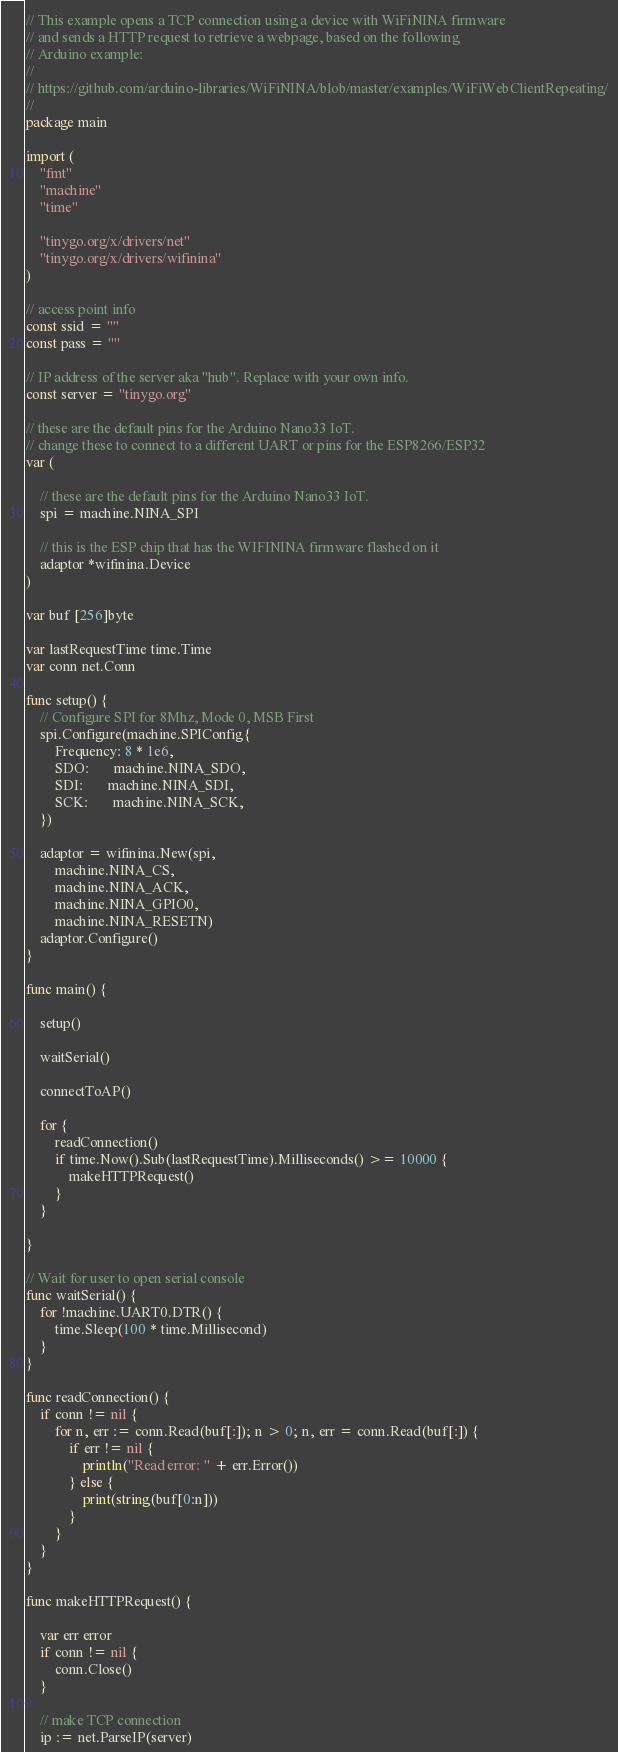<code> <loc_0><loc_0><loc_500><loc_500><_Go_>// This example opens a TCP connection using a device with WiFiNINA firmware
// and sends a HTTP request to retrieve a webpage, based on the following
// Arduino example:
//
// https://github.com/arduino-libraries/WiFiNINA/blob/master/examples/WiFiWebClientRepeating/
//
package main

import (
	"fmt"
	"machine"
	"time"

	"tinygo.org/x/drivers/net"
	"tinygo.org/x/drivers/wifinina"
)

// access point info
const ssid = ""
const pass = ""

// IP address of the server aka "hub". Replace with your own info.
const server = "tinygo.org"

// these are the default pins for the Arduino Nano33 IoT.
// change these to connect to a different UART or pins for the ESP8266/ESP32
var (

	// these are the default pins for the Arduino Nano33 IoT.
	spi = machine.NINA_SPI

	// this is the ESP chip that has the WIFININA firmware flashed on it
	adaptor *wifinina.Device
)

var buf [256]byte

var lastRequestTime time.Time
var conn net.Conn

func setup() {
	// Configure SPI for 8Mhz, Mode 0, MSB First
	spi.Configure(machine.SPIConfig{
		Frequency: 8 * 1e6,
		SDO:       machine.NINA_SDO,
		SDI:       machine.NINA_SDI,
		SCK:       machine.NINA_SCK,
	})

	adaptor = wifinina.New(spi,
		machine.NINA_CS,
		machine.NINA_ACK,
		machine.NINA_GPIO0,
		machine.NINA_RESETN)
	adaptor.Configure()
}

func main() {

	setup()

	waitSerial()

	connectToAP()

	for {
		readConnection()
		if time.Now().Sub(lastRequestTime).Milliseconds() >= 10000 {
			makeHTTPRequest()
		}
	}

}

// Wait for user to open serial console
func waitSerial() {
	for !machine.UART0.DTR() {
		time.Sleep(100 * time.Millisecond)
	}
}

func readConnection() {
	if conn != nil {
		for n, err := conn.Read(buf[:]); n > 0; n, err = conn.Read(buf[:]) {
			if err != nil {
				println("Read error: " + err.Error())
			} else {
				print(string(buf[0:n]))
			}
		}
	}
}

func makeHTTPRequest() {

	var err error
	if conn != nil {
		conn.Close()
	}

	// make TCP connection
	ip := net.ParseIP(server)</code> 